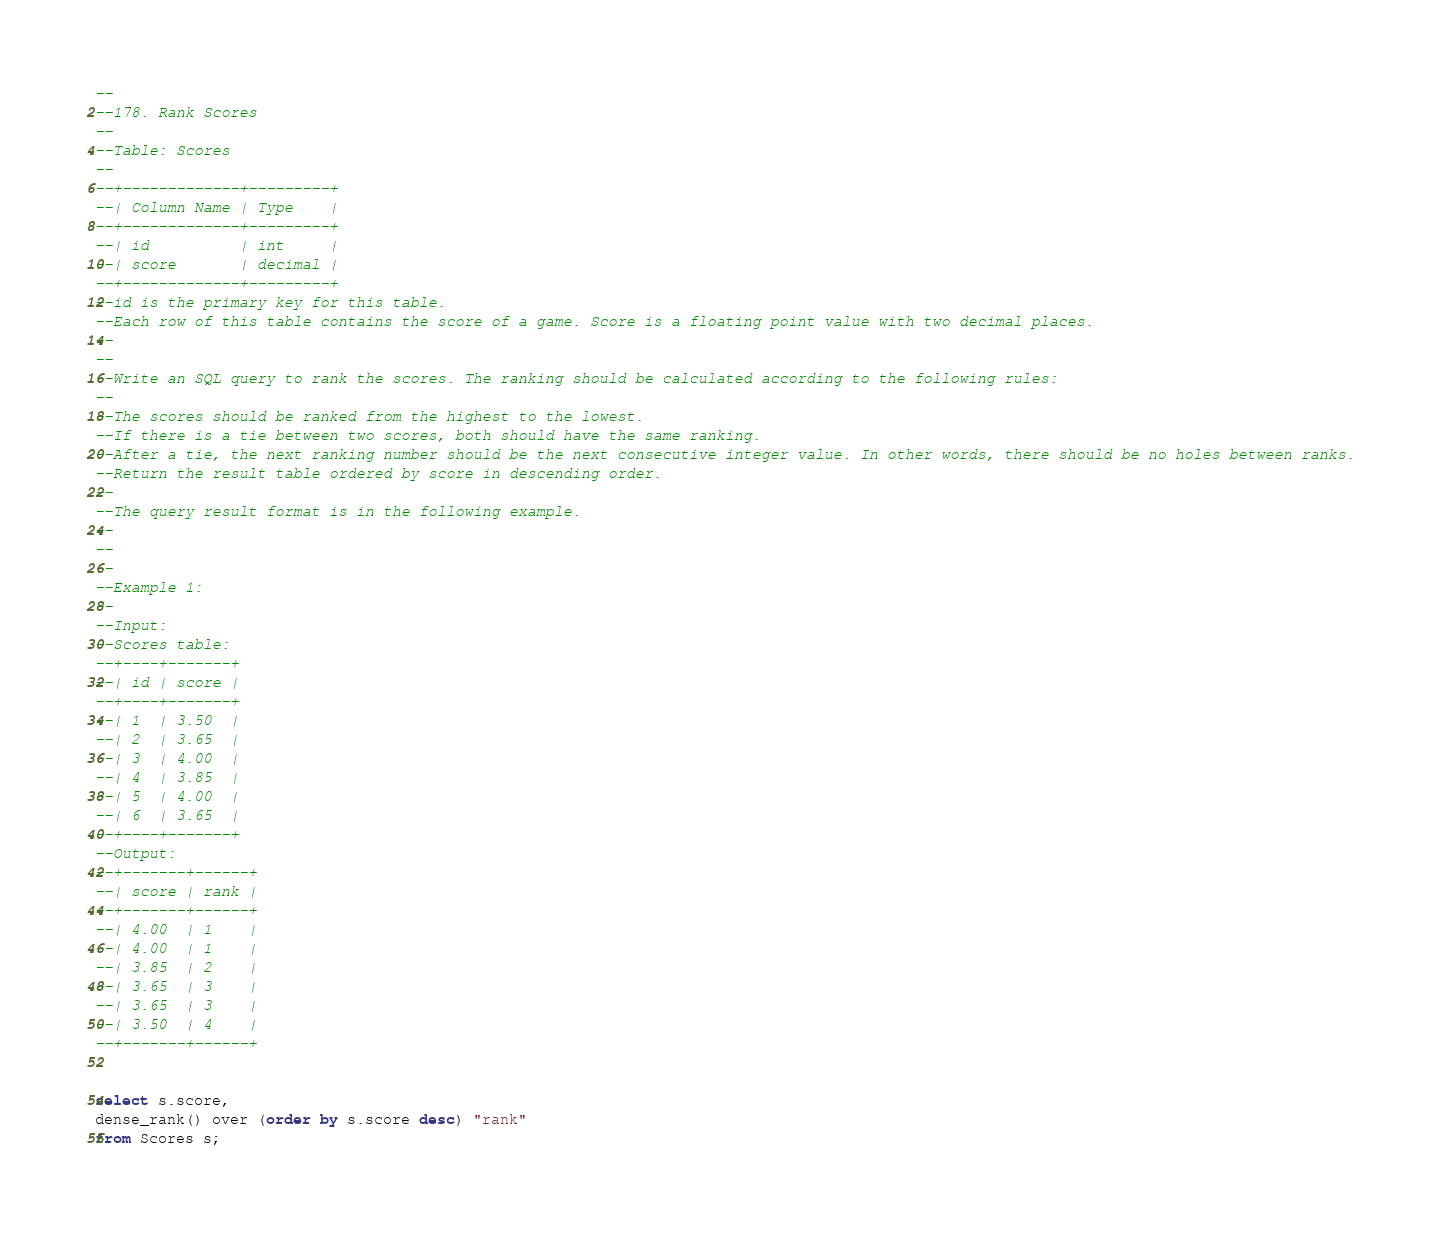<code> <loc_0><loc_0><loc_500><loc_500><_SQL_>--
--178. Rank Scores
--
--Table: Scores
--
--+-------------+---------+
--| Column Name | Type    |
--+-------------+---------+
--| id          | int     |
--| score       | decimal |
--+-------------+---------+
--id is the primary key for this table.
--Each row of this table contains the score of a game. Score is a floating point value with two decimal places.
-- 
--
--Write an SQL query to rank the scores. The ranking should be calculated according to the following rules:
--
--The scores should be ranked from the highest to the lowest.
--If there is a tie between two scores, both should have the same ranking.
--After a tie, the next ranking number should be the next consecutive integer value. In other words, there should be no holes between ranks.
--Return the result table ordered by score in descending order.
--
--The query result format is in the following example.
--
-- 
--
--Example 1:
--
--Input: 
--Scores table:
--+----+-------+
--| id | score |
--+----+-------+
--| 1  | 3.50  |
--| 2  | 3.65  |
--| 3  | 4.00  |
--| 4  | 3.85  |
--| 5  | 4.00  |
--| 6  | 3.65  |
--+----+-------+
--Output: 
--+-------+------+
--| score | rank |
--+-------+------+
--| 4.00  | 1    |
--| 4.00  | 1    |
--| 3.85  | 2    |
--| 3.65  | 3    |
--| 3.65  | 3    |
--| 3.50  | 4    |
--+-------+------+


select s.score,
dense_rank() over (order by s.score desc) "rank"
from Scores s;









</code> 